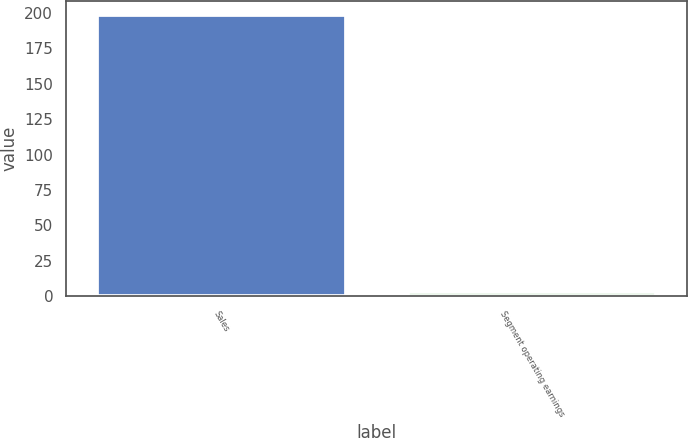<chart> <loc_0><loc_0><loc_500><loc_500><bar_chart><fcel>Sales<fcel>Segment operating earnings<nl><fcel>198.4<fcel>3<nl></chart> 